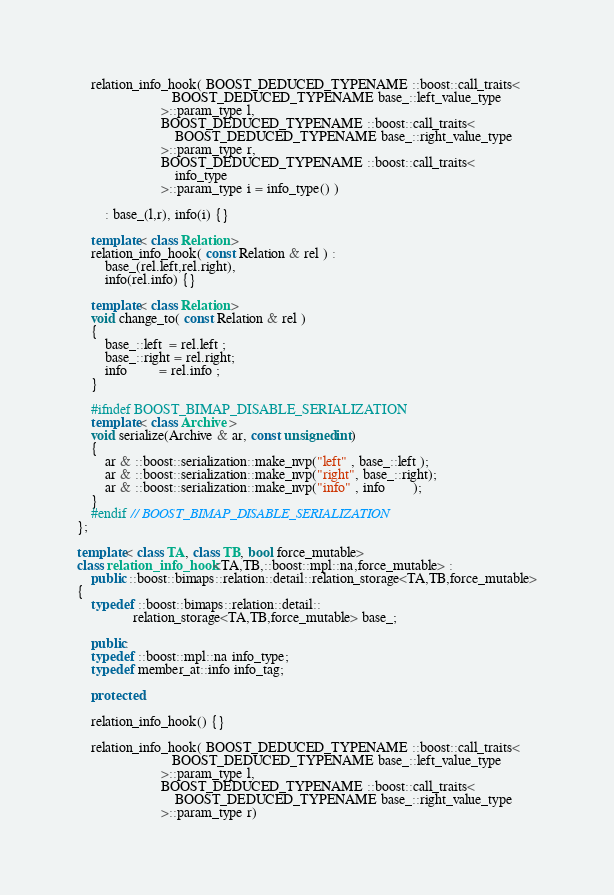Convert code to text. <code><loc_0><loc_0><loc_500><loc_500><_C++_>
    relation_info_hook( BOOST_DEDUCED_TYPENAME ::boost::call_traits<
                           BOOST_DEDUCED_TYPENAME base_::left_value_type
                        >::param_type l,
                        BOOST_DEDUCED_TYPENAME ::boost::call_traits<
                            BOOST_DEDUCED_TYPENAME base_::right_value_type
                        >::param_type r,
                        BOOST_DEDUCED_TYPENAME ::boost::call_traits<
                            info_type
                        >::param_type i = info_type() )

        : base_(l,r), info(i) {}

    template< class Relation >
    relation_info_hook( const Relation & rel ) :
        base_(rel.left,rel.right),
        info(rel.info) {}

    template< class Relation >
    void change_to( const Relation & rel )
    {
        base_::left  = rel.left ;
        base_::right = rel.right;
        info         = rel.info ;
    }

    #ifndef BOOST_BIMAP_DISABLE_SERIALIZATION
    template< class Archive >
    void serialize(Archive & ar, const unsigned int)
    {
        ar & ::boost::serialization::make_nvp("left" , base_::left );
        ar & ::boost::serialization::make_nvp("right", base_::right);
        ar & ::boost::serialization::make_nvp("info" , info        );
    }
    #endif // BOOST_BIMAP_DISABLE_SERIALIZATION
};

template< class TA, class TB, bool force_mutable>
class relation_info_hook<TA,TB,::boost::mpl::na,force_mutable> :
    public ::boost::bimaps::relation::detail::relation_storage<TA,TB,force_mutable>
{
    typedef ::boost::bimaps::relation::detail::
                relation_storage<TA,TB,force_mutable> base_;

    public:
    typedef ::boost::mpl::na info_type;
    typedef member_at::info info_tag;

    protected:

    relation_info_hook() {}

    relation_info_hook( BOOST_DEDUCED_TYPENAME ::boost::call_traits<
                           BOOST_DEDUCED_TYPENAME base_::left_value_type
                        >::param_type l,
                        BOOST_DEDUCED_TYPENAME ::boost::call_traits<
                            BOOST_DEDUCED_TYPENAME base_::right_value_type
                        >::param_type r)
</code> 